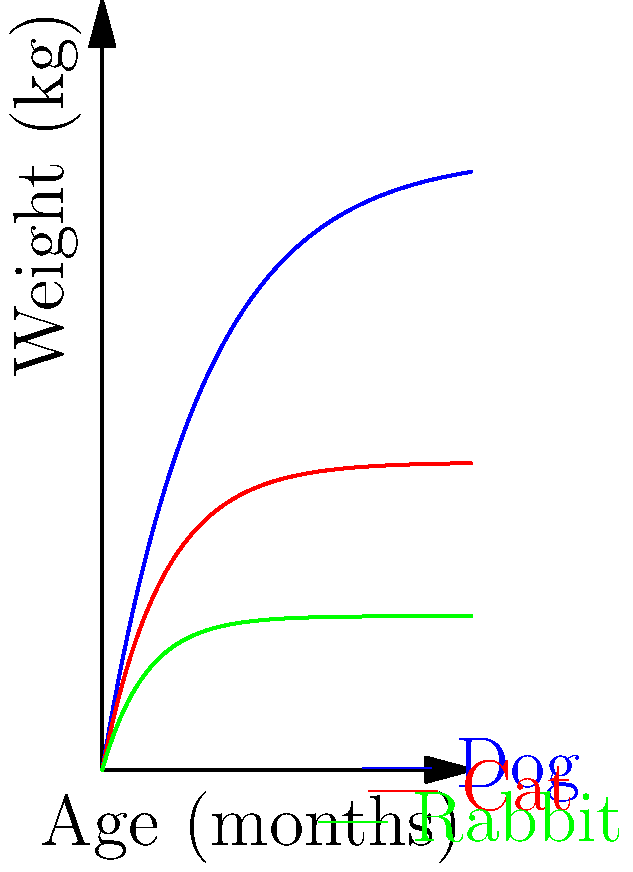Based on the growth charts for different animal species, at approximately what age (in months) does a cat reach half of its adult weight? To determine when a cat reaches half of its adult weight, we need to follow these steps:

1. Observe the growth curve for cats (red line) on the chart.
2. Identify the asymptote of the cat's growth curve, which represents the adult weight. From the graph, we can see that the cat's weight approaches about 10 kg.
3. Calculate half of the adult weight: $\frac{10}{2} = 5$ kg.
4. Locate the point on the cat's growth curve where it crosses the 5 kg mark on the y-axis.
5. Project this point onto the x-axis to determine the corresponding age.

From the graph, we can see that the cat's growth curve crosses the 5 kg mark at approximately 1.5 months.

This aligns with the exponential growth model used in the graph:

$W(t) = W_{\infty}(1 - e^{-kt})$

Where $W(t)$ is the weight at time $t$, $W_{\infty}$ is the adult weight, and $k$ is the growth rate constant.

For cats, $W_{\infty} = 10$ kg and $k = 0.5$ (based on the Asymptote code).

To find when the weight is half the adult weight:

$5 = 10(1 - e^{-0.5t})$
$0.5 = 1 - e^{-0.5t}$
$e^{-0.5t} = 0.5$
$-0.5t = \ln(0.5)$
$t = -\frac{\ln(0.5)}{0.5} \approx 1.39$ months

This calculation confirms our visual estimation from the graph.
Answer: 1.5 months 